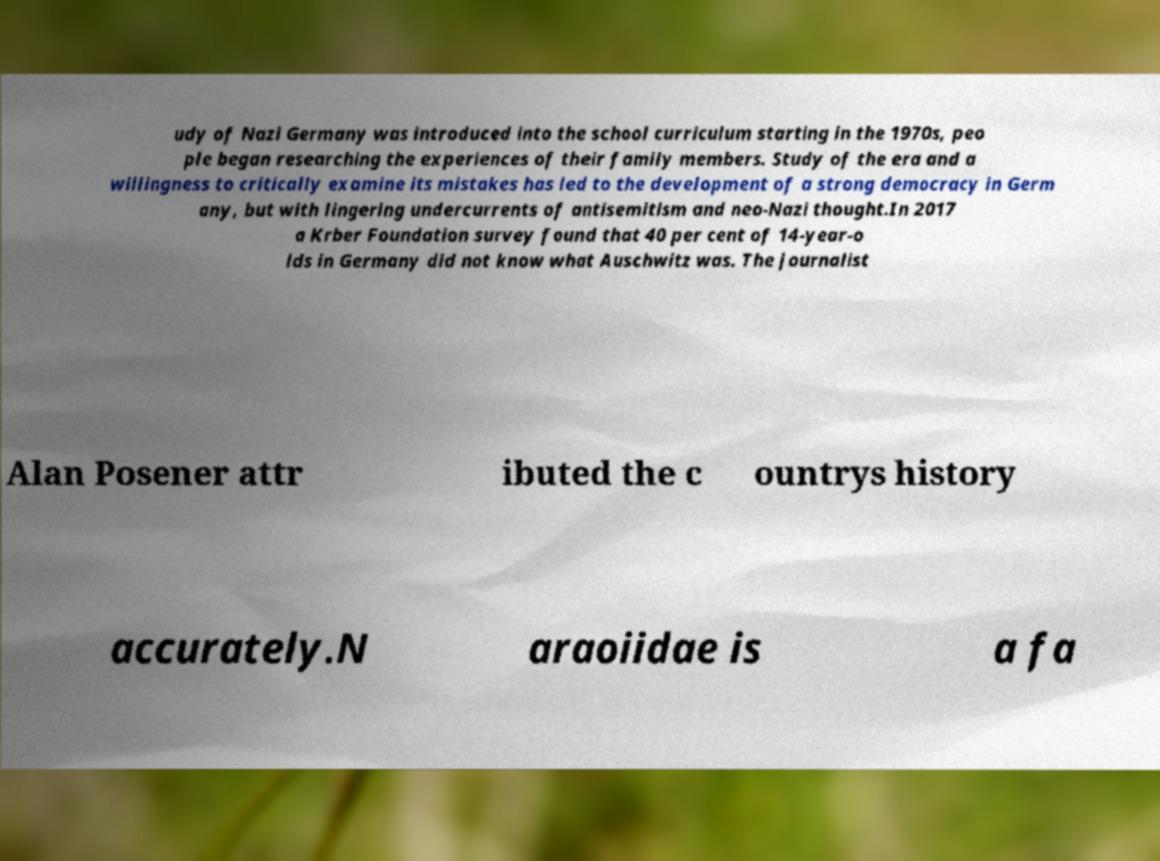Could you extract and type out the text from this image? udy of Nazi Germany was introduced into the school curriculum starting in the 1970s, peo ple began researching the experiences of their family members. Study of the era and a willingness to critically examine its mistakes has led to the development of a strong democracy in Germ any, but with lingering undercurrents of antisemitism and neo-Nazi thought.In 2017 a Krber Foundation survey found that 40 per cent of 14-year-o lds in Germany did not know what Auschwitz was. The journalist Alan Posener attr ibuted the c ountrys history accurately.N araoiidae is a fa 